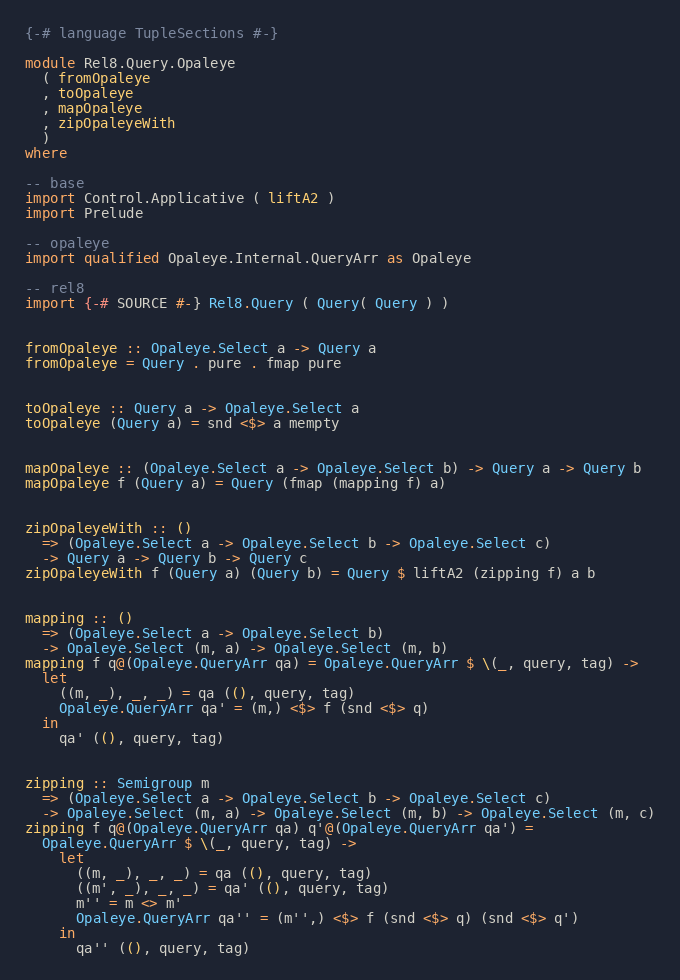<code> <loc_0><loc_0><loc_500><loc_500><_Haskell_>{-# language TupleSections #-}

module Rel8.Query.Opaleye
  ( fromOpaleye
  , toOpaleye
  , mapOpaleye
  , zipOpaleyeWith
  )
where

-- base
import Control.Applicative ( liftA2 )
import Prelude

-- opaleye
import qualified Opaleye.Internal.QueryArr as Opaleye

-- rel8
import {-# SOURCE #-} Rel8.Query ( Query( Query ) )


fromOpaleye :: Opaleye.Select a -> Query a
fromOpaleye = Query . pure . fmap pure


toOpaleye :: Query a -> Opaleye.Select a
toOpaleye (Query a) = snd <$> a mempty


mapOpaleye :: (Opaleye.Select a -> Opaleye.Select b) -> Query a -> Query b
mapOpaleye f (Query a) = Query (fmap (mapping f) a)


zipOpaleyeWith :: ()
  => (Opaleye.Select a -> Opaleye.Select b -> Opaleye.Select c)
  -> Query a -> Query b -> Query c
zipOpaleyeWith f (Query a) (Query b) = Query $ liftA2 (zipping f) a b


mapping :: ()
  => (Opaleye.Select a -> Opaleye.Select b)
  -> Opaleye.Select (m, a) -> Opaleye.Select (m, b)
mapping f q@(Opaleye.QueryArr qa) = Opaleye.QueryArr $ \(_, query, tag) ->
  let
    ((m, _), _, _) = qa ((), query, tag)
    Opaleye.QueryArr qa' = (m,) <$> f (snd <$> q)
  in
    qa' ((), query, tag)


zipping :: Semigroup m
  => (Opaleye.Select a -> Opaleye.Select b -> Opaleye.Select c)
  -> Opaleye.Select (m, a) -> Opaleye.Select (m, b) -> Opaleye.Select (m, c)
zipping f q@(Opaleye.QueryArr qa) q'@(Opaleye.QueryArr qa') =
  Opaleye.QueryArr $ \(_, query, tag) ->
    let
      ((m, _), _, _) = qa ((), query, tag)
      ((m', _), _, _) = qa' ((), query, tag)
      m'' = m <> m'
      Opaleye.QueryArr qa'' = (m'',) <$> f (snd <$> q) (snd <$> q')
    in
      qa'' ((), query, tag)
</code> 